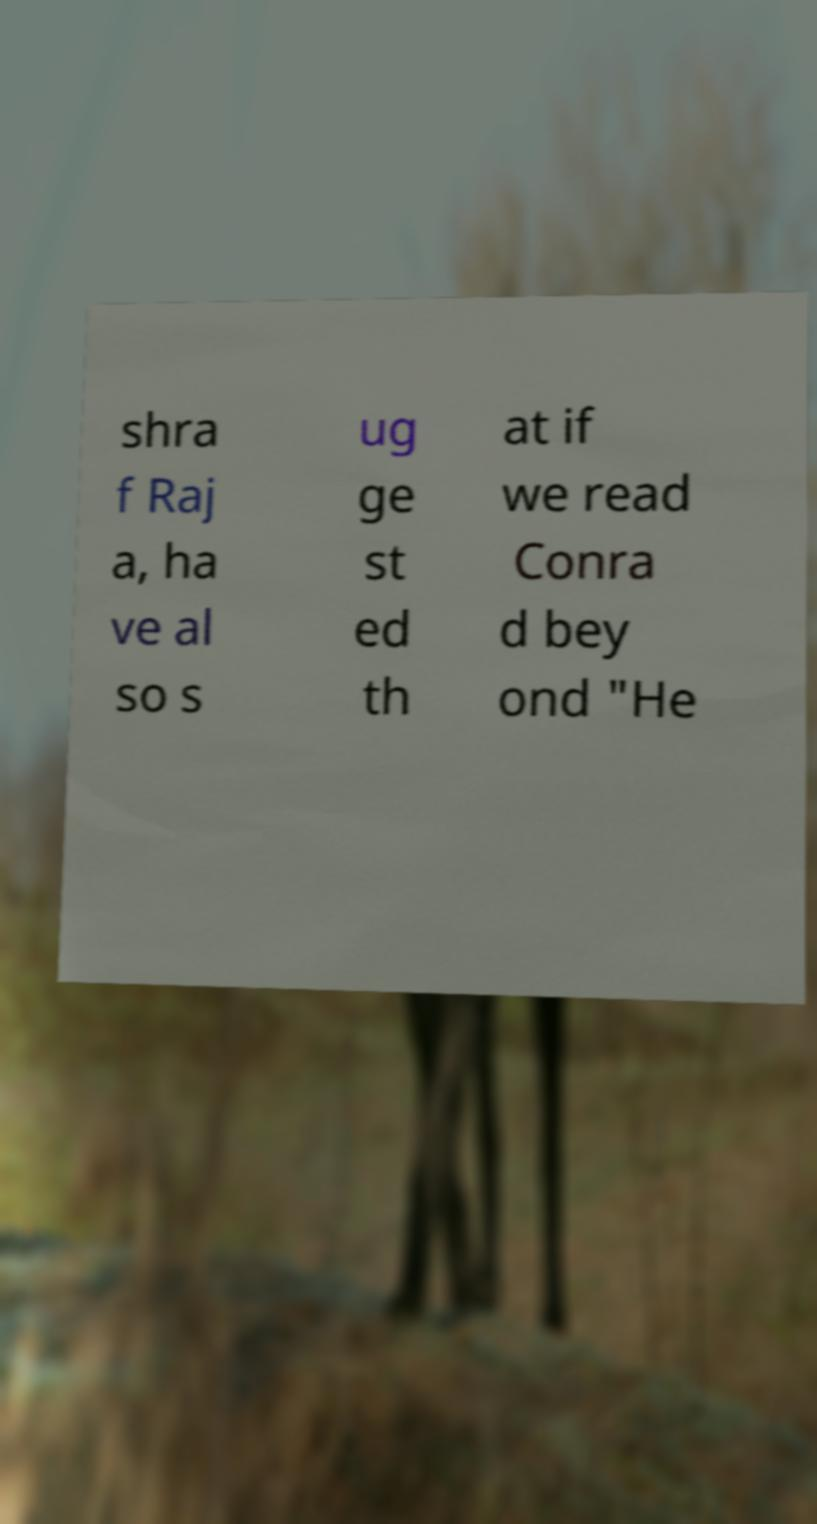Please identify and transcribe the text found in this image. shra f Raj a, ha ve al so s ug ge st ed th at if we read Conra d bey ond "He 